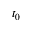Convert formula to latex. <formula><loc_0><loc_0><loc_500><loc_500>t _ { 0 }</formula> 